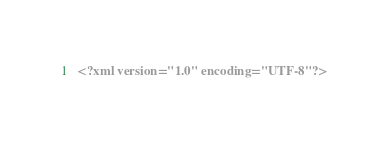Convert code to text. <code><loc_0><loc_0><loc_500><loc_500><_XML_><?xml version="1.0" encoding="UTF-8"?></code> 